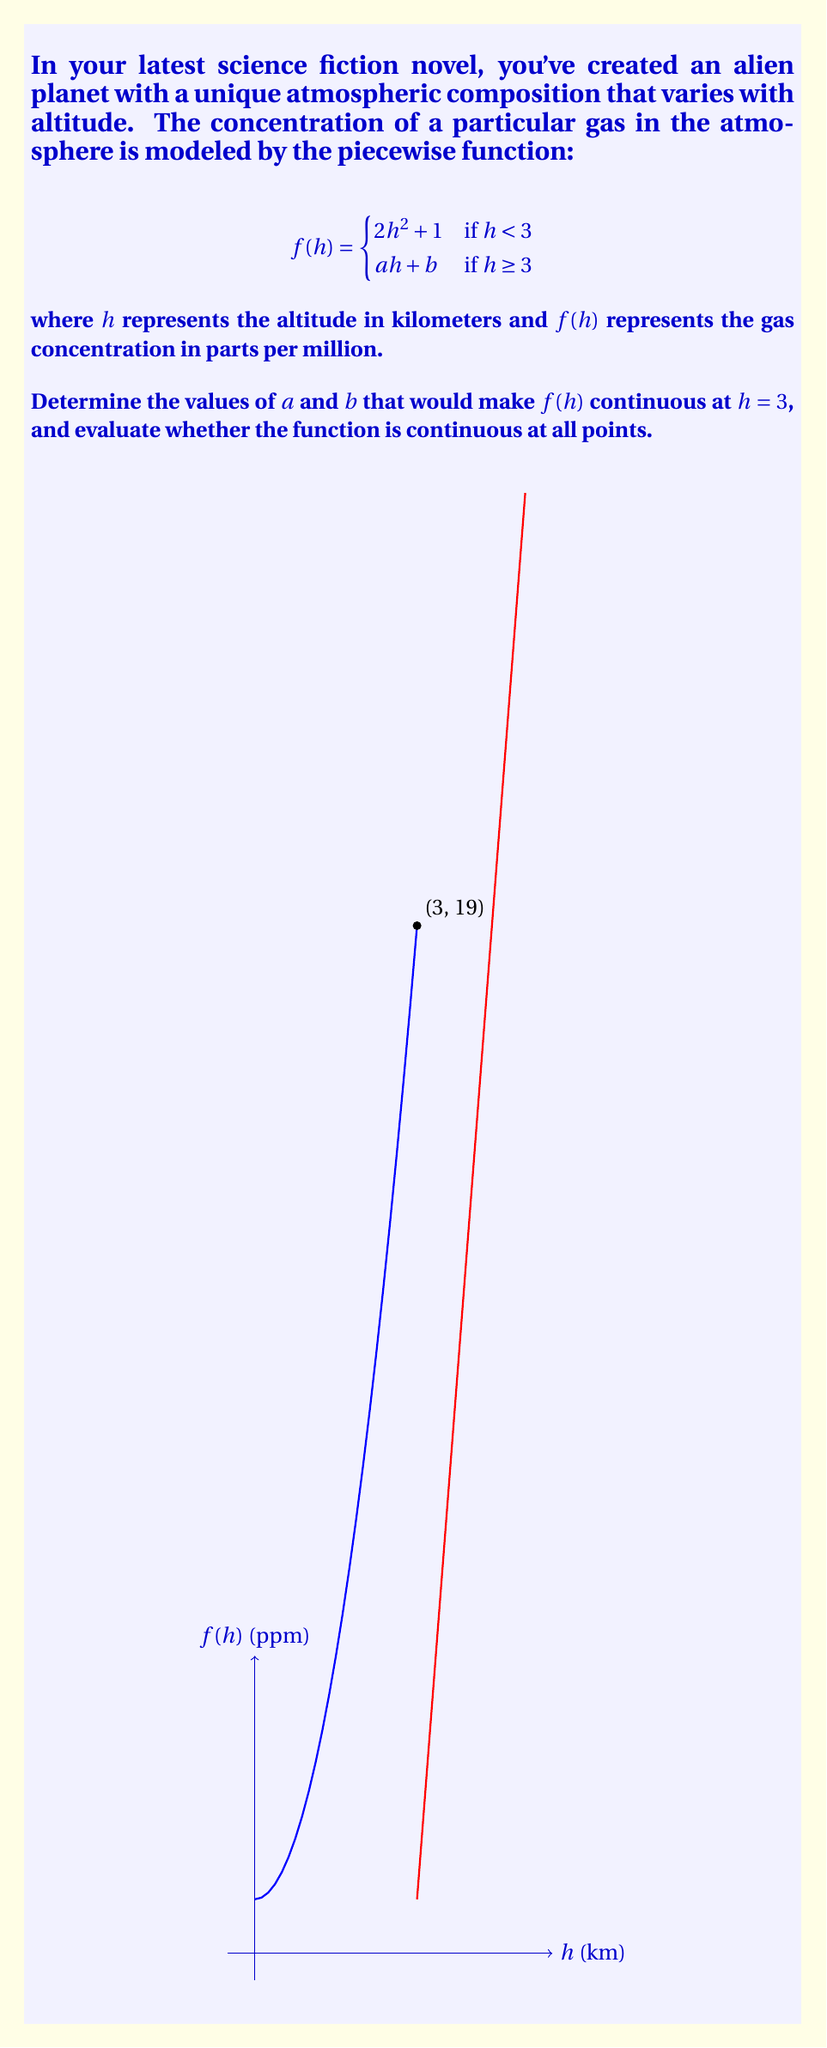Provide a solution to this math problem. To determine if $f(h)$ is continuous at $h = 3$, we need to check if the function satisfies the three conditions of continuity:

1. $f(3)$ is defined from the left side
2. $\lim_{h \to 3^-} f(h)$ exists
3. $\lim_{h \to 3^-} f(h) = f(3)$

Let's evaluate these conditions:

1. $f(3)$ from the left side:
   $$f(3) = 2(3)^2 + 1 = 18 + 1 = 19$$

2. $\lim_{h \to 3^-} f(h) = \lim_{h \to 3^-} (2h^2 + 1) = 2(3)^2 + 1 = 19$

3. For the function to be continuous at $h = 3$, we need:
   $$\lim_{h \to 3^+} f(h) = \lim_{h \to 3^-} f(h) = f(3)$$

   This means:
   $$a(3) + b = 19$$

We also need the derivative to be continuous at $h = 3$ for the function to be smooth:

$$\lim_{h \to 3^-} f'(h) = \lim_{h \to 3^+} f'(h)$$

The left-hand derivative:
$$f'(h) = 4h \quad \text{when } h < 3$$
$$\lim_{h \to 3^-} f'(h) = 4(3) = 12$$

The right-hand derivative:
$$f'(h) = a \quad \text{when } h \geq 3$$

For continuity of the derivative:
$$a = 12$$

Now we have two equations:
1. $3a + b = 19$
2. $a = 12$

Substituting $a = 12$ into the first equation:
$$3(12) + b = 19$$
$$36 + b = 19$$
$$b = -17$$

Therefore, $a = 12$ and $b = -17$.

The complete piecewise function is:

$$f(h) = \begin{cases}
2h^2 + 1 & \text{if } h < 3 \\
12h - 17 & \text{if } h \geq 3
\end{cases}$$

This function is continuous at $h = 3$ and at all other points because:
1. It's continuous for all $h < 3$ (polynomial function)
2. It's continuous for all $h > 3$ (linear function)
3. It's continuous at $h = 3$ (we made it so)

Thus, the function is continuous at all points.
Answer: $a = 12$, $b = -17$; The function is continuous at all points. 